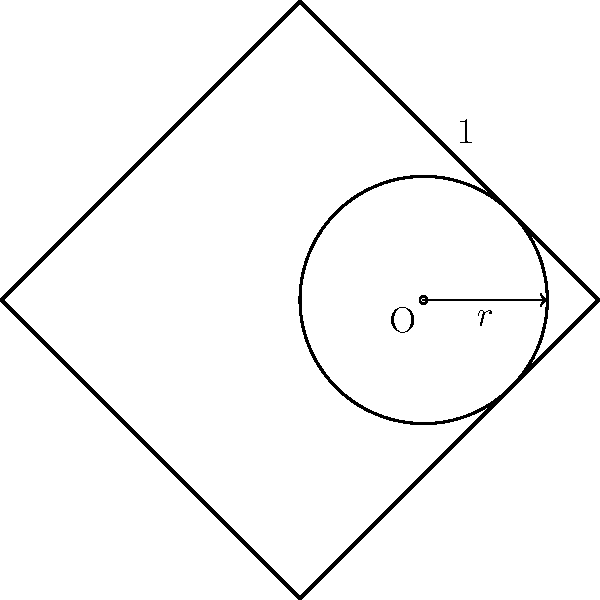In the context of religious symbolism, consider a cross symbol formed by four equal-length arms, each with a length of 1 unit. A circle is inscribed within this cross, touching all four arms. What is the circumference of this inscribed circle? To find the circumference of the inscribed circle, we need to follow these steps:

1) First, we need to determine the radius of the inscribed circle. In a cross with equal arms of length 1, the radius of the inscribed circle is equal to the distance from the center to one of the arms.

2) The cross can be inscribed in a square with side length 2. The radius of the circle is half the width of this square minus half the width of the cross arm.

3) Therefore, the radius $r$ can be calculated as:
   $r = 1 - \frac{1}{2} = \frac{1}{2}$

4) Now that we have the radius, we can use the formula for the circumference of a circle:
   $C = 2\pi r$

5) Substituting our radius value:
   $C = 2\pi (\frac{1}{2}) = \pi$

Thus, the circumference of the inscribed circle is $\pi$ units.
Answer: $\pi$ units 